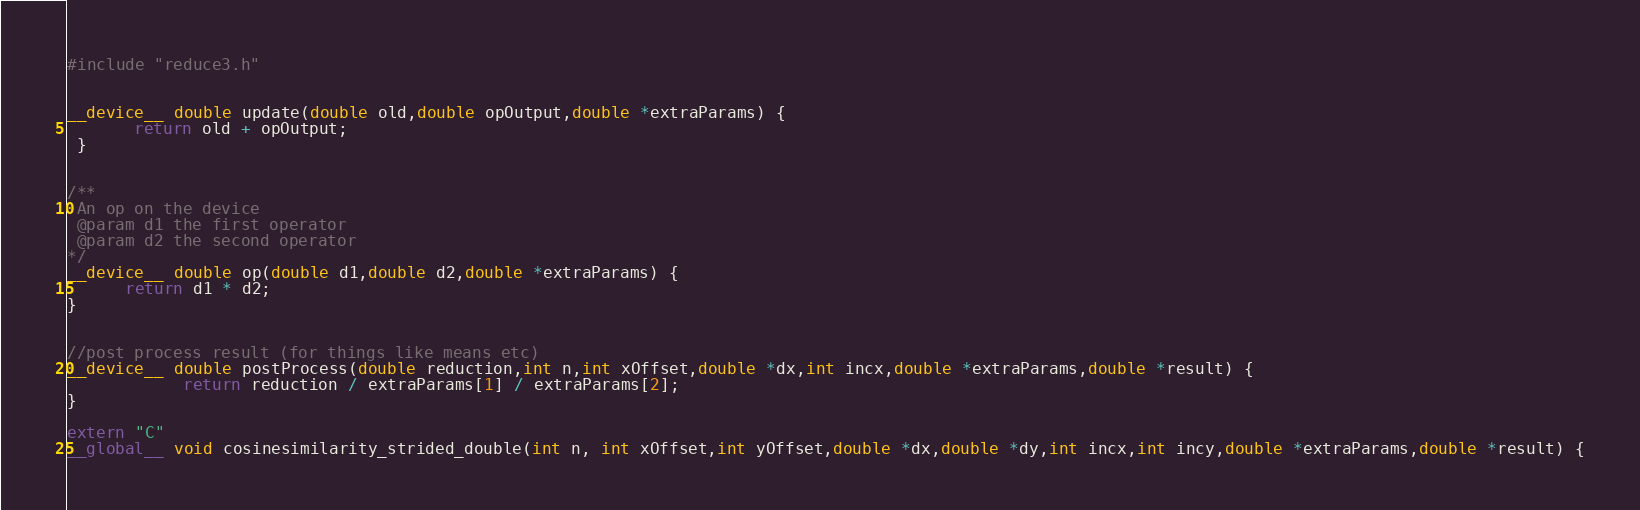<code> <loc_0><loc_0><loc_500><loc_500><_Cuda_>#include "reduce3.h"


__device__ double update(double old,double opOutput,double *extraParams) {
       return old + opOutput;
 }


/**
 An op on the device
 @param d1 the first operator
 @param d2 the second operator
*/
__device__ double op(double d1,double d2,double *extraParams) {
      return d1 * d2;
}


//post process result (for things like means etc)
__device__ double postProcess(double reduction,int n,int xOffset,double *dx,int incx,double *extraParams,double *result) {
            return reduction / extraParams[1] / extraParams[2];
}

extern "C"
__global__ void cosinesimilarity_strided_double(int n, int xOffset,int yOffset,double *dx,double *dy,int incx,int incy,double *extraParams,double *result) {</code> 